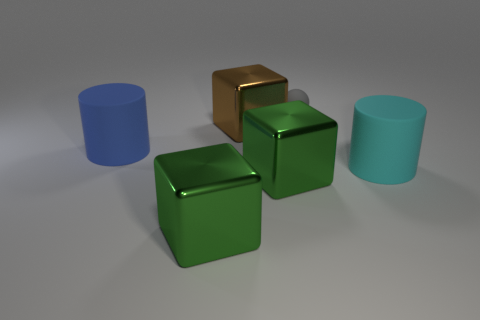Add 4 things. How many objects exist? 10 Subtract all balls. How many objects are left? 5 Subtract all brown things. Subtract all brown metallic objects. How many objects are left? 4 Add 6 shiny things. How many shiny things are left? 9 Add 3 small balls. How many small balls exist? 4 Subtract 1 cyan cylinders. How many objects are left? 5 